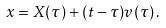<formula> <loc_0><loc_0><loc_500><loc_500>x = X ( \tau ) + ( t - \tau ) v ( \tau ) \, .</formula> 